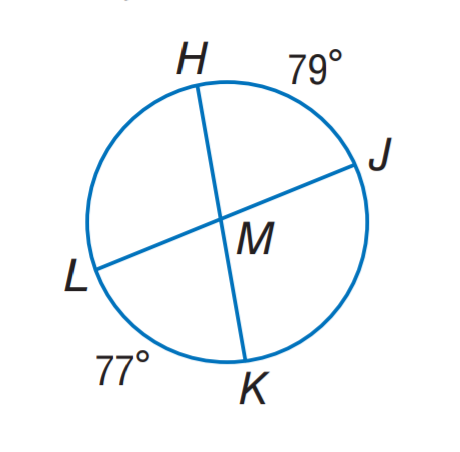Question: Find m \angle J M K.
Choices:
A. 79
B. 101
C. 102
D. 103
Answer with the letter. Answer: C 